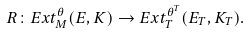<formula> <loc_0><loc_0><loc_500><loc_500>R \colon E x t _ { M } ^ { \theta } ( E , K ) \to E x t _ { T } ^ { \theta ^ { T } } ( E _ { T } , K _ { T } ) .</formula> 